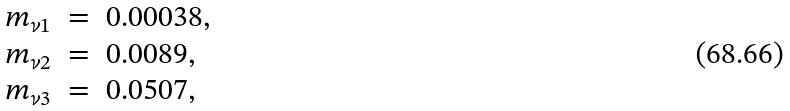Convert formula to latex. <formula><loc_0><loc_0><loc_500><loc_500>\begin{array} { r c l } m _ { \nu 1 } & = & 0 . 0 0 0 3 8 , \\ m _ { \nu 2 } & = & 0 . 0 0 8 9 , \\ m _ { \nu 3 } & = & 0 . 0 5 0 7 , \end{array}</formula> 